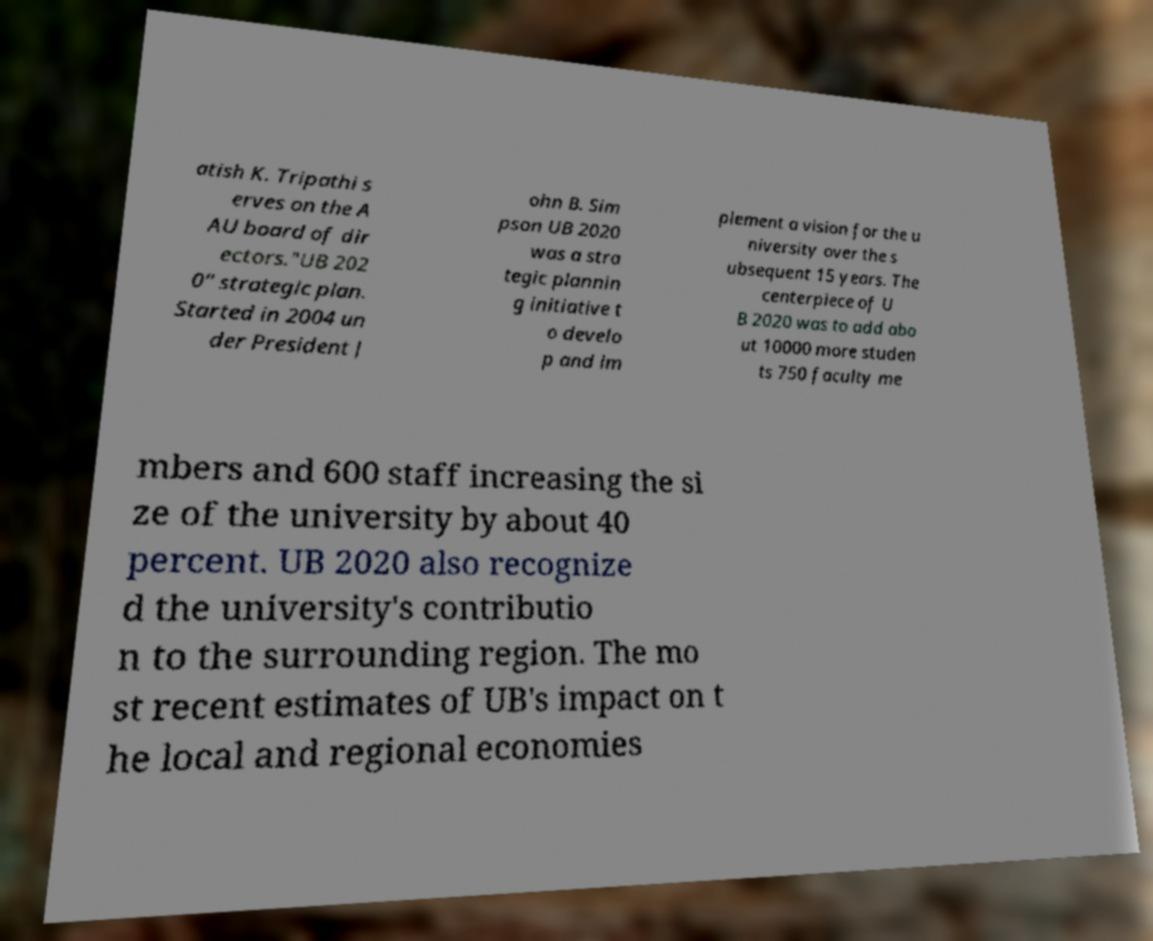For documentation purposes, I need the text within this image transcribed. Could you provide that? atish K. Tripathi s erves on the A AU board of dir ectors."UB 202 0" strategic plan. Started in 2004 un der President J ohn B. Sim pson UB 2020 was a stra tegic plannin g initiative t o develo p and im plement a vision for the u niversity over the s ubsequent 15 years. The centerpiece of U B 2020 was to add abo ut 10000 more studen ts 750 faculty me mbers and 600 staff increasing the si ze of the university by about 40 percent. UB 2020 also recognize d the university's contributio n to the surrounding region. The mo st recent estimates of UB's impact on t he local and regional economies 